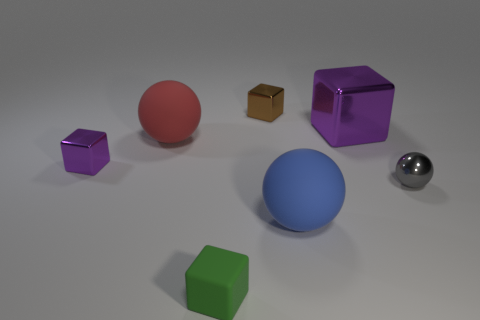What material is the purple cube left of the tiny green block?
Your response must be concise. Metal. The other brown metallic object that is the same shape as the large metal thing is what size?
Your answer should be compact. Small. What number of big objects have the same material as the small purple object?
Your answer should be very brief. 1. What number of small shiny things have the same color as the large cube?
Your answer should be compact. 1. What number of things are either large balls that are to the right of the green object or purple objects that are to the right of the brown block?
Give a very brief answer. 2. Is the number of purple metal blocks on the left side of the big blue rubber sphere less than the number of big blue cubes?
Provide a succinct answer. No. Are there any gray metal things of the same size as the blue thing?
Ensure brevity in your answer.  No. What is the color of the large cube?
Make the answer very short. Purple. Is the blue matte sphere the same size as the brown object?
Your answer should be very brief. No. How many things are either brown cylinders or metallic balls?
Keep it short and to the point. 1. 